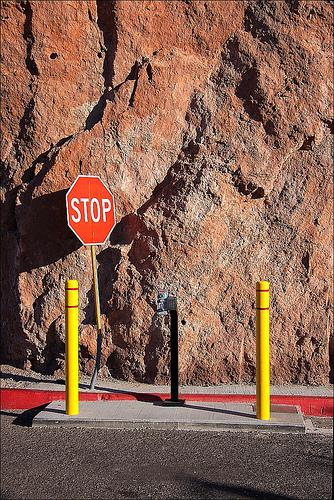Question: where was this photo taken?
Choices:
A. Close to the hills.
B. Close to the top of mount Rose.
C. Close to the side of the mountain.
D. On a hill side.
Answer with the letter. Answer: C Question: what are they on?
Choices:
A. A train.
B. A road.
C. A couch.
D. A path in the park.
Answer with the letter. Answer: B Question: who is present?
Choices:
A. A huge crowd.
B. Two old men.
C. A monkey.
D. Nobody.
Answer with the letter. Answer: D Question: when was this?
Choices:
A. Night.
B. Daytime.
C. Dusk.
D. St. Patrick's Day.
Answer with the letter. Answer: B 